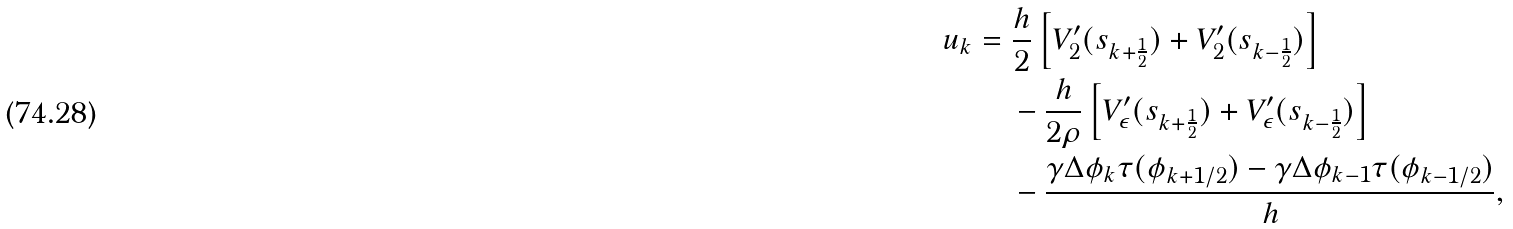Convert formula to latex. <formula><loc_0><loc_0><loc_500><loc_500>u _ { k } & = \frac { h } { 2 } \left [ V _ { 2 } ^ { \prime } ( s _ { k + \frac { 1 } { 2 } } ) + V _ { 2 } ^ { \prime } ( s _ { k - \frac { 1 } { 2 } } ) \right ] \\ & \quad \, - \frac { h } { 2 \rho } \left [ V _ { \epsilon } ^ { \prime } ( s _ { k + \frac { 1 } { 2 } } ) + V _ { \epsilon } ^ { \prime } ( s _ { k - \frac { 1 } { 2 } } ) \right ] \\ & \quad \, - \frac { \gamma \Delta \phi _ { k } \tau ( \phi _ { k + 1 / 2 } ) - \gamma \Delta \phi _ { k - 1 } \tau ( \phi _ { k - 1 / 2 } ) } { h } ,</formula> 